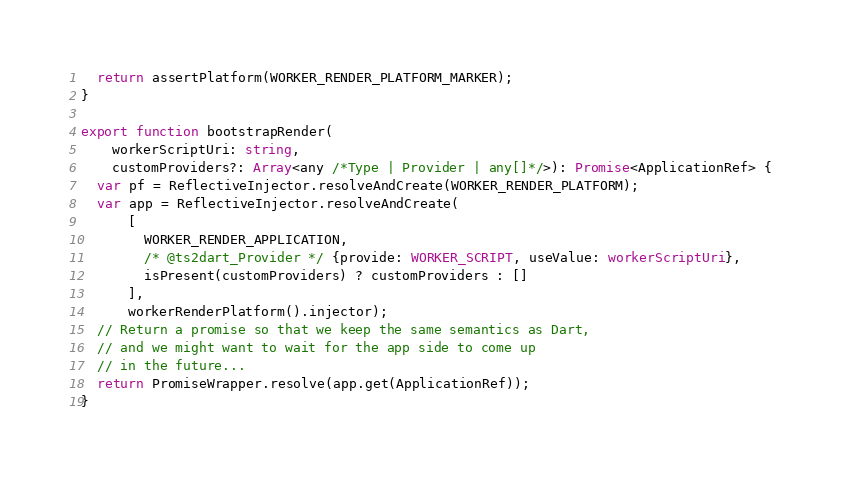Convert code to text. <code><loc_0><loc_0><loc_500><loc_500><_TypeScript_>  return assertPlatform(WORKER_RENDER_PLATFORM_MARKER);
}

export function bootstrapRender(
    workerScriptUri: string,
    customProviders?: Array<any /*Type | Provider | any[]*/>): Promise<ApplicationRef> {
  var pf = ReflectiveInjector.resolveAndCreate(WORKER_RENDER_PLATFORM);
  var app = ReflectiveInjector.resolveAndCreate(
      [
        WORKER_RENDER_APPLICATION,
        /* @ts2dart_Provider */ {provide: WORKER_SCRIPT, useValue: workerScriptUri},
        isPresent(customProviders) ? customProviders : []
      ],
      workerRenderPlatform().injector);
  // Return a promise so that we keep the same semantics as Dart,
  // and we might want to wait for the app side to come up
  // in the future...
  return PromiseWrapper.resolve(app.get(ApplicationRef));
}
</code> 